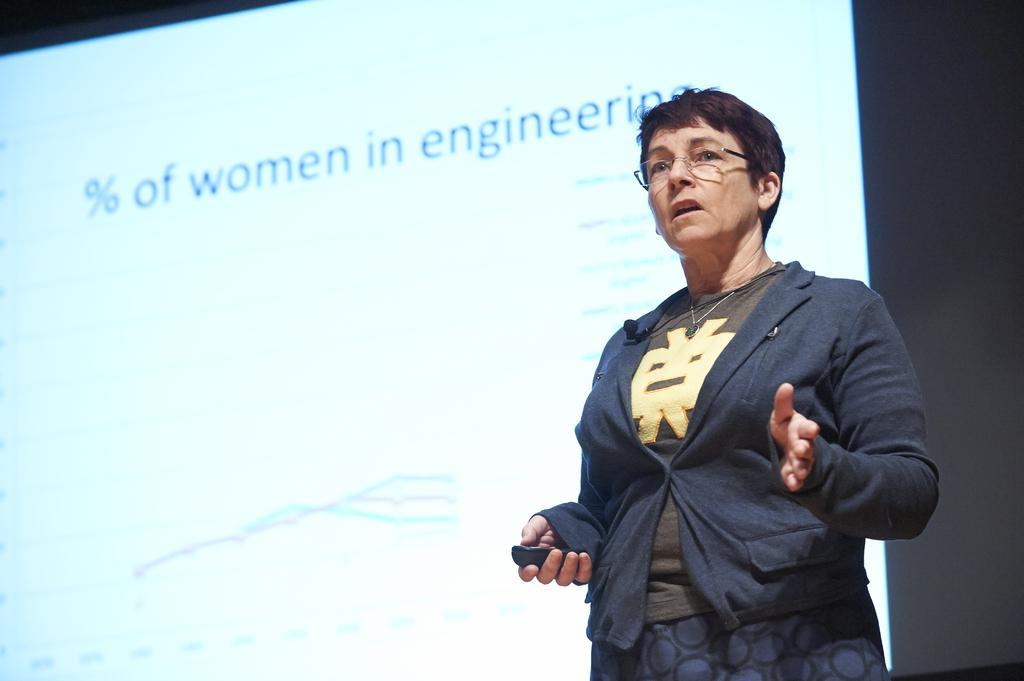Can you describe this image briefly? There is one woman standing and holding an object on the right side of this image, and there is a screen on the wall as we can see in the background. 